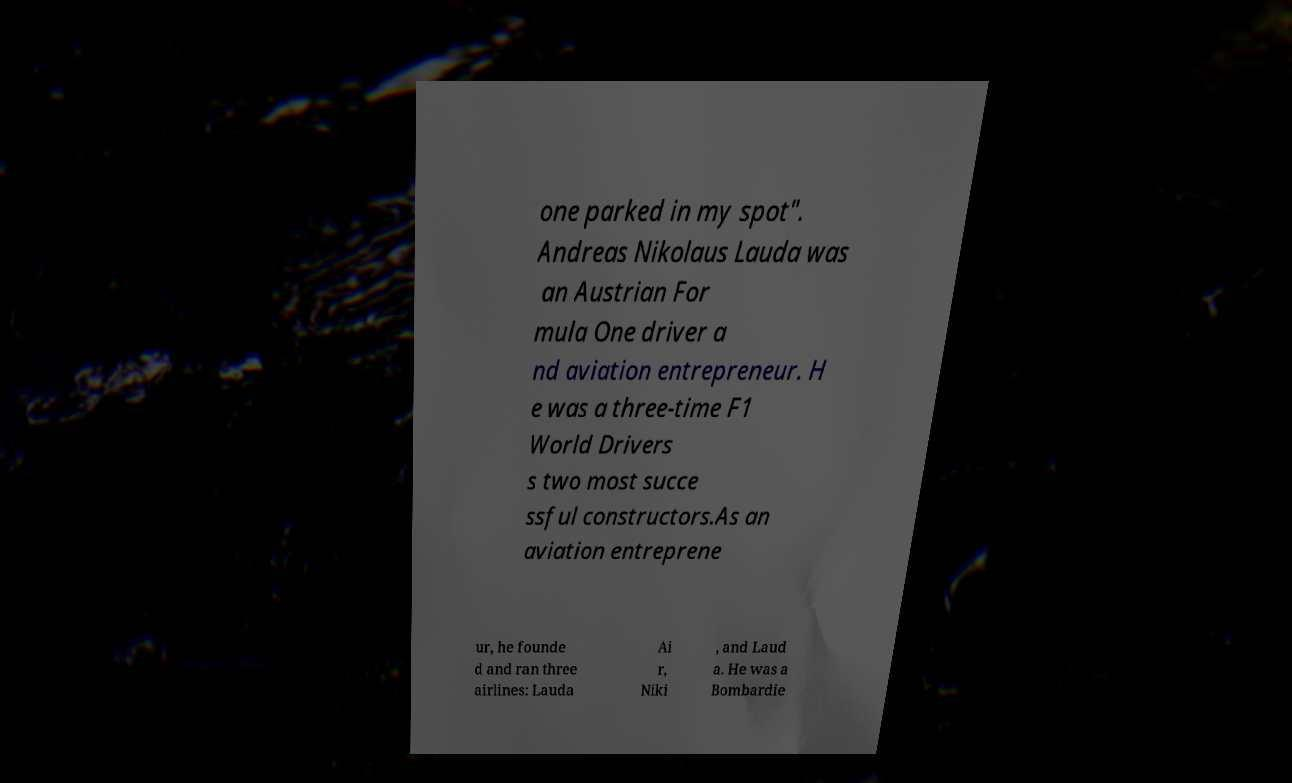Could you assist in decoding the text presented in this image and type it out clearly? one parked in my spot". Andreas Nikolaus Lauda was an Austrian For mula One driver a nd aviation entrepreneur. H e was a three-time F1 World Drivers s two most succe ssful constructors.As an aviation entreprene ur, he founde d and ran three airlines: Lauda Ai r, Niki , and Laud a. He was a Bombardie 